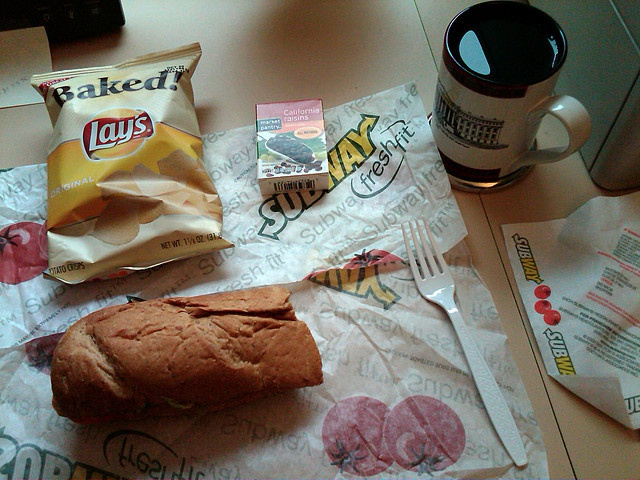Describe the objects in this image and their specific colors. I can see dining table in darkgray, black, gray, and maroon tones, sandwich in black, maroon, gray, and brown tones, cup in black, maroon, and gray tones, and fork in black, darkgray, lightblue, and gray tones in this image. 